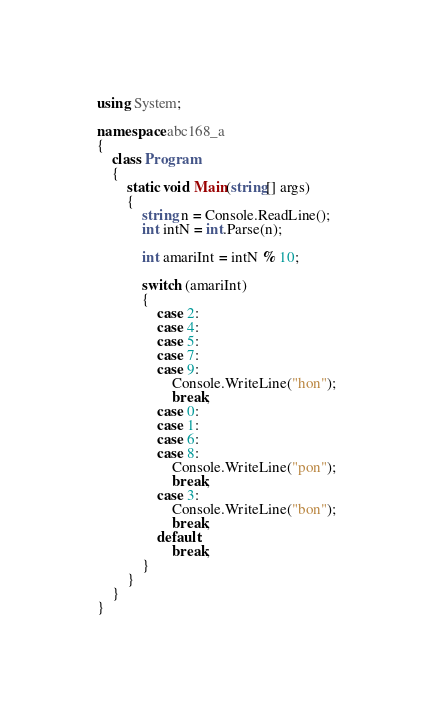Convert code to text. <code><loc_0><loc_0><loc_500><loc_500><_C#_>using System;

namespace abc168_a
{
    class Program
    {
        static void Main(string[] args)
        {
            string n = Console.ReadLine();
            int intN = int.Parse(n);

            int amariInt = intN % 10;

            switch (amariInt)
            {
                case 2:
                case 4:
                case 5:
                case 7:
                case 9:
                    Console.WriteLine("hon");
                    break;
                case 0:
                case 1:
                case 6:
                case 8:
                    Console.WriteLine("pon");
                    break;
                case 3:
                    Console.WriteLine("bon");
                    break;
                default:
                    break;
            }
        }
    }
}
</code> 